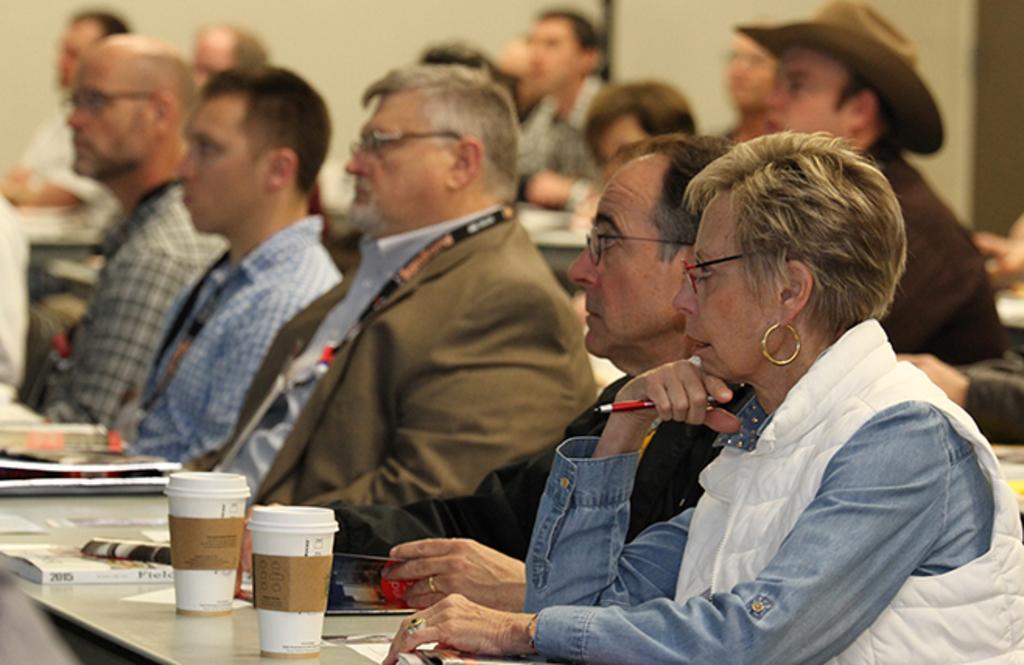In one or two sentences, can you explain what this image depicts? There are people sitting and she is holding a pen, we can see glasses, books and papers on tables. In the background we can see wall. 